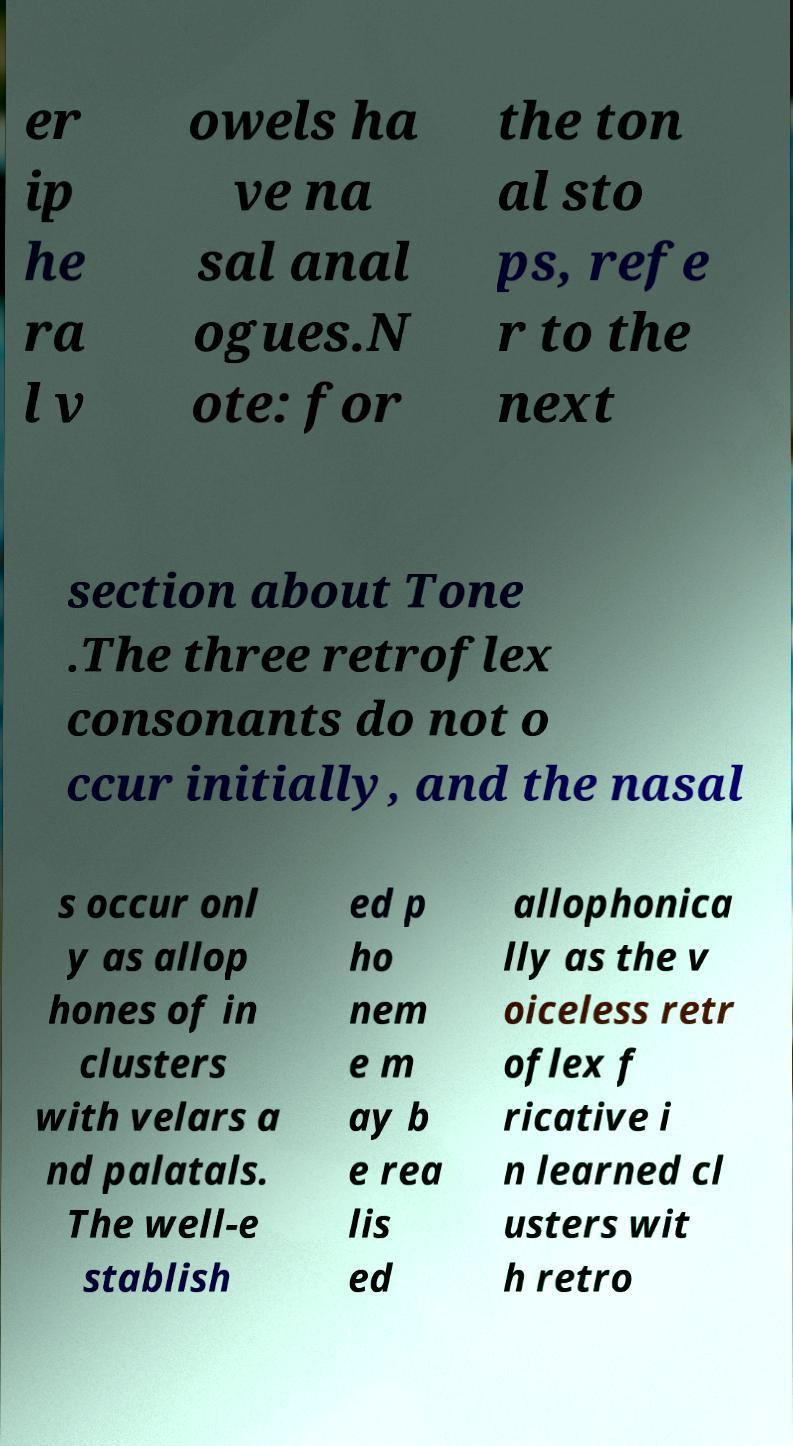I need the written content from this picture converted into text. Can you do that? er ip he ra l v owels ha ve na sal anal ogues.N ote: for the ton al sto ps, refe r to the next section about Tone .The three retroflex consonants do not o ccur initially, and the nasal s occur onl y as allop hones of in clusters with velars a nd palatals. The well-e stablish ed p ho nem e m ay b e rea lis ed allophonica lly as the v oiceless retr oflex f ricative i n learned cl usters wit h retro 